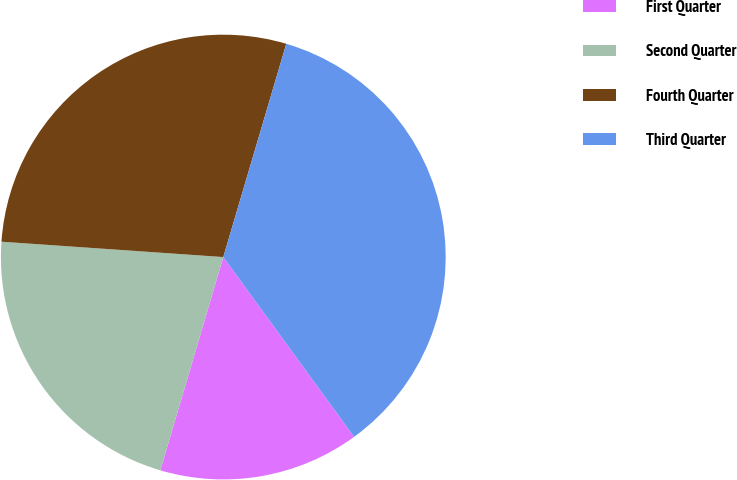<chart> <loc_0><loc_0><loc_500><loc_500><pie_chart><fcel>First Quarter<fcel>Second Quarter<fcel>Fourth Quarter<fcel>Third Quarter<nl><fcel>14.58%<fcel>21.53%<fcel>28.47%<fcel>35.42%<nl></chart> 